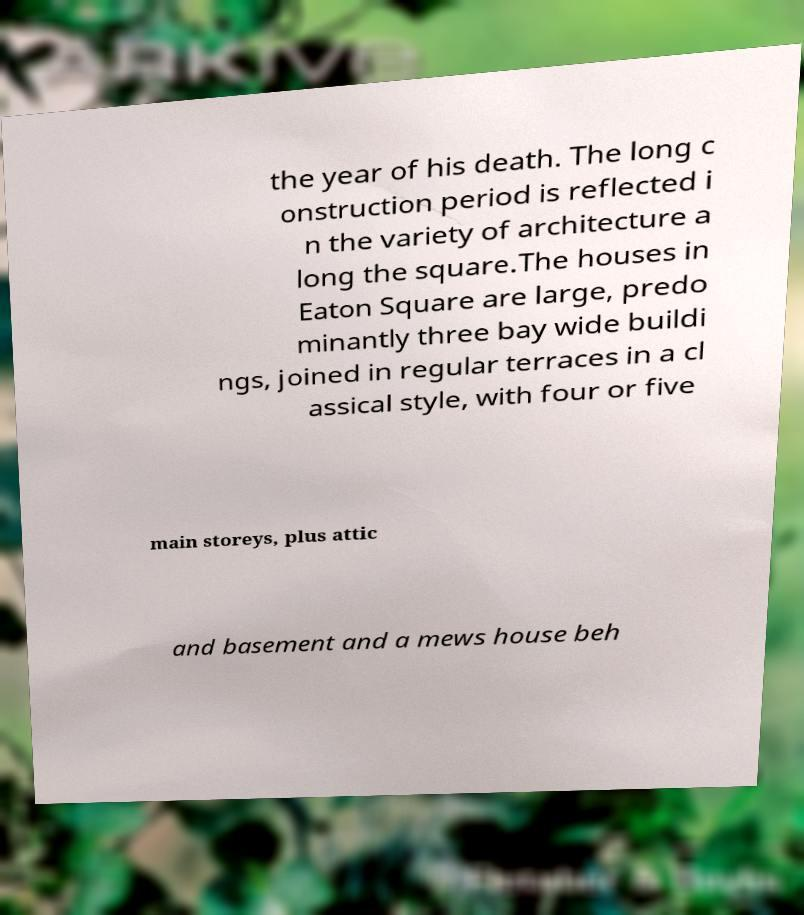What messages or text are displayed in this image? I need them in a readable, typed format. the year of his death. The long c onstruction period is reflected i n the variety of architecture a long the square.The houses in Eaton Square are large, predo minantly three bay wide buildi ngs, joined in regular terraces in a cl assical style, with four or five main storeys, plus attic and basement and a mews house beh 